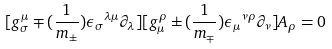Convert formula to latex. <formula><loc_0><loc_0><loc_500><loc_500>[ g ^ { \mu } _ { \sigma } \mp ( \frac { 1 } { m _ { \pm } } ) { \epsilon _ { \sigma } } ^ { \lambda \mu } \partial _ { \lambda } ] [ g ^ { \rho } _ { \mu } \pm ( \frac { 1 } { m _ { \mp } } ) { \epsilon _ { \mu } } ^ { \nu \rho } \partial _ { \nu } ] A _ { \rho } = 0</formula> 